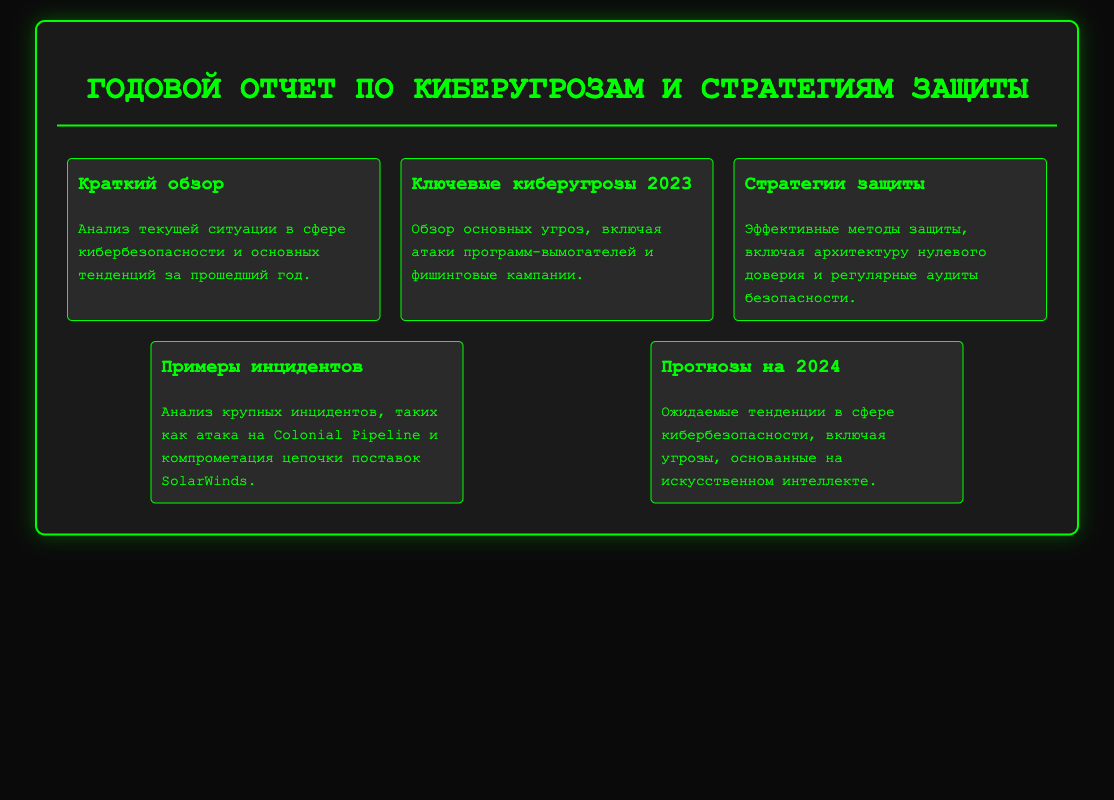Что включает краткий обзор? Краткий обзор включает анализ текущей ситуации в сфере кибербезопасности и основных тенденций за прошедший год.
Answer: Анализ текущей ситуации в сфере кибербезопасности Какие ключевые киберугрозы указаны в 2023 году? В разделе «Ключевые киберугрозы 2023» указаны угрозы, такие как атаки программ-вымогателей и фишинговые кампании.
Answer: Атаки программ-вымогателей и фишинговые кампании Каковы эффективные методы защиты? В разделе «Стратегии защиты» представлены эффективные методы защиты, включая архитектуру нулевого доверия и регулярные аудиты безопасности.
Answer: Архитектура нулевого доверия и регулярные аудиты безопасности Какие крупные инциденты анализируются? В разделе «Примеры инцидентов» анализируются инциденты, такие как атака на Colonial Pipeline и компрометация цепочки поставок SolarWinds.
Answer: Атака на Colonial Pipeline и компрометация цепочки поставок SolarWinds Какие прогнозы на 2024 год? В разделе «Прогнозы на 2024» рассматриваются ожидаемые тенденции, включая угрозы, основанные на искусственном интеллекте.
Answer: Угрозы, основанные на искусственном интеллекте 